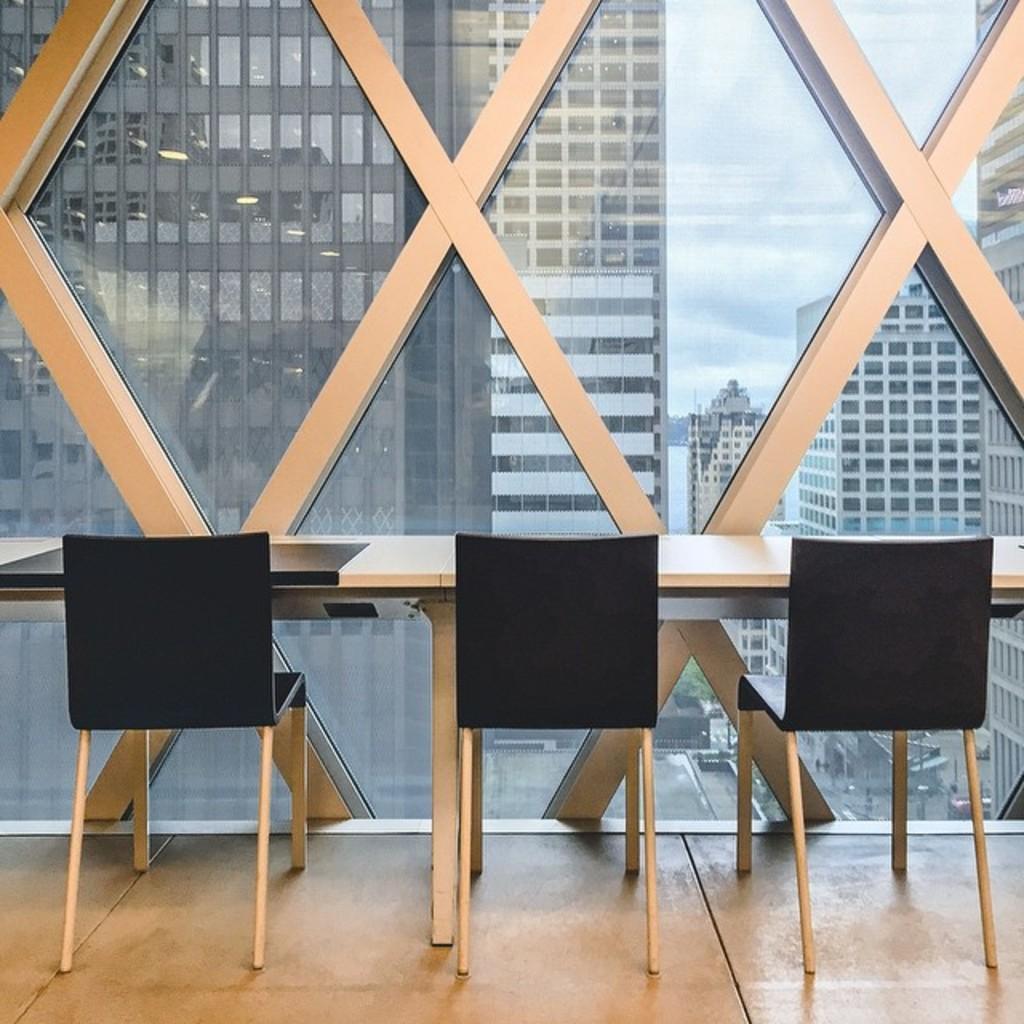Please provide a concise description of this image. In this picture I can observe three black color chairs in front of the tables. In the background I can observe buildings and some clouds in the sky. 